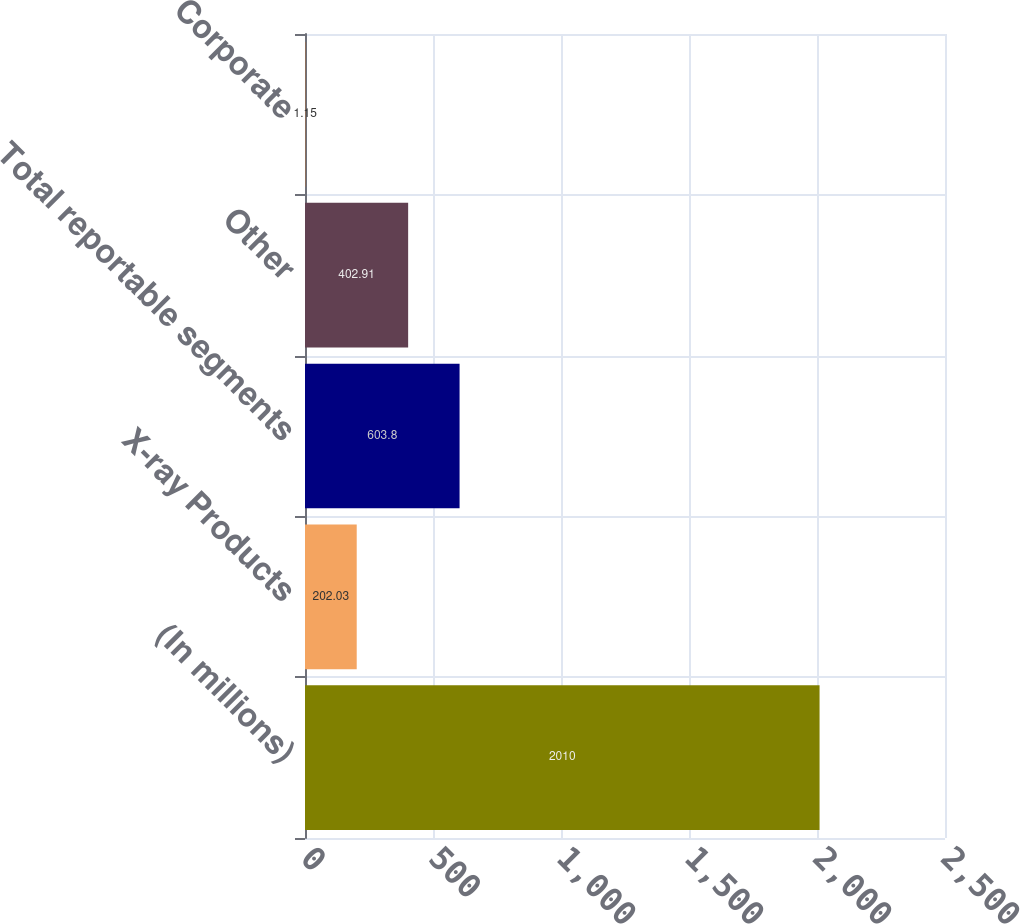Convert chart to OTSL. <chart><loc_0><loc_0><loc_500><loc_500><bar_chart><fcel>(In millions)<fcel>X-ray Products<fcel>Total reportable segments<fcel>Other<fcel>Corporate<nl><fcel>2010<fcel>202.03<fcel>603.8<fcel>402.91<fcel>1.15<nl></chart> 